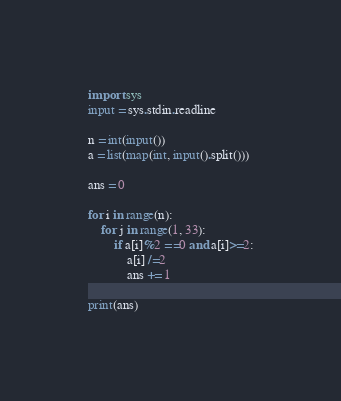Convert code to text. <code><loc_0><loc_0><loc_500><loc_500><_Python_>import sys
input = sys.stdin.readline

n = int(input())
a = list(map(int, input().split()))

ans = 0

for i in range(n):
    for j in range(1, 33):
        if a[i]%2 ==0 and a[i]>=2:
            a[i] /=2
            ans += 1

print(ans)</code> 